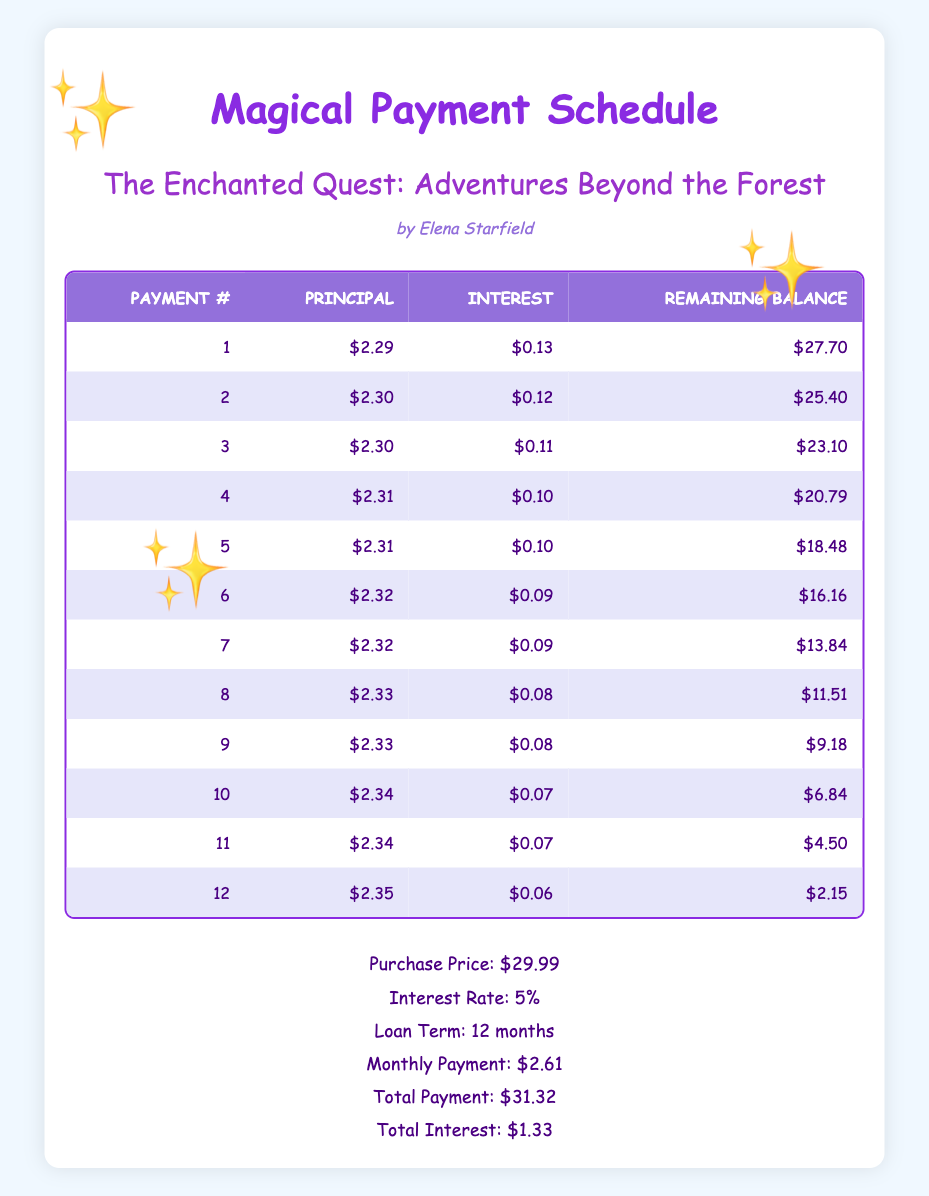What is the monthly payment for this book? The monthly payment for this book is listed in the summary section of the table, which states $2.61.
Answer: 2.61 How much total will I pay once the loan is completed? The total payment is provided in the summary section of the table, which indicates a total payment of $31.32.
Answer: 31.32 What is the principal payment for the 5th payment? To find the principal payment for the 5th payment, we refer to the payment schedule specifically for payment number 5, which shows it is $2.31.
Answer: 2.31 Does the interest payment decrease over time? By looking at the interest payments listed for each payment number, we can see that they start at $0.13 and decrease each month to $0.06 by the 12th payment, indicating a decreasing trend.
Answer: Yes What is the remaining balance after the 7th payment? The remaining balance for the 7th payment can be found in the payment schedule where payment number 7 is listed. It shows a remaining balance of $13.84 after this payment.
Answer: 13.84 How much total interest will I pay throughout the loan? The total interest payment is directly given in the summary section of the table, which indicates a total interest of $1.33 across the entire loan term.
Answer: 1.33 What is the average principal payment made over the 12 payments? To calculate the average principal payment, we first sum the principal payments from each monthly payment: (2.29 + 2.30 + ... + 2.35) = 27.99, then divide by 12, giving us an average principal payment of 27.99 / 12 = 2.33.
Answer: 2.33 How much did the remaining balance decrease from the first payment to the last payment? The remaining balance after the first payment was $27.70, and after the last (12th) payment, it is $2.15. The change in remaining balance can be calculated as $27.70 - $2.15 = $25.55.
Answer: 25.55 In which month is the principal payment highest? By examining the principal payments across all 12 months, we see that the highest principal payment occurs in the 12th month at $2.35.
Answer: 12th month 